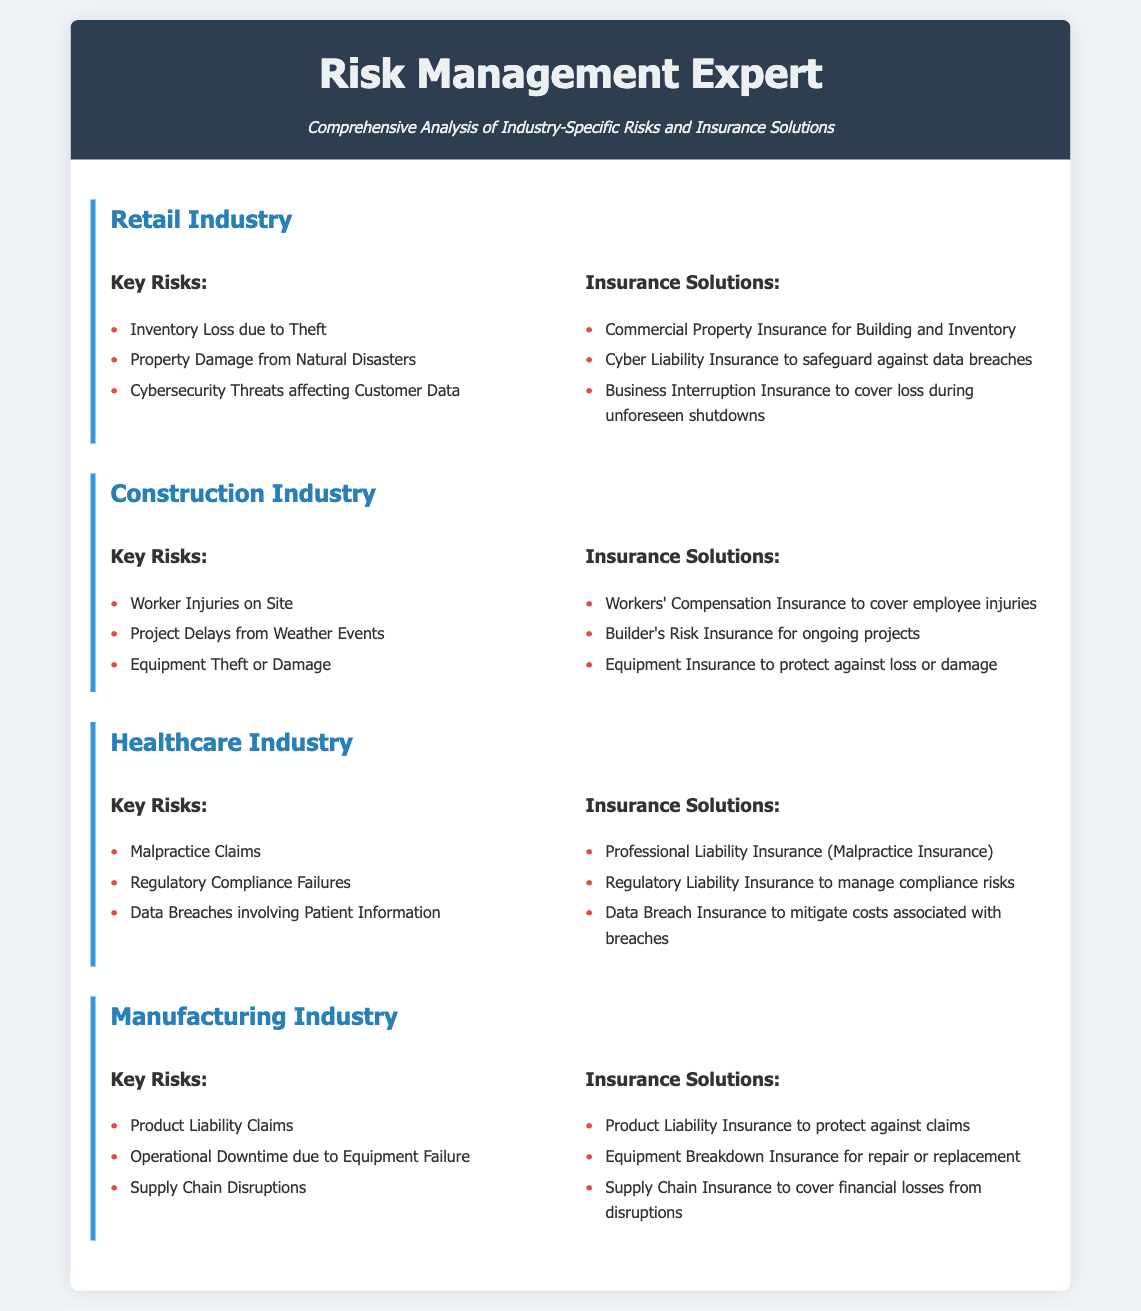What are the key risks in the Retail Industry? The key risks listed are Inventory Loss due to Theft, Property Damage from Natural Disasters, and Cybersecurity Threats affecting Customer Data.
Answer: Inventory Loss due to Theft, Property Damage from Natural Disasters, Cybersecurity Threats affecting Customer Data What type of insurance protects against worker injuries in the Construction Industry? The specific insurance mentioned for worker injuries is Workers' Compensation Insurance.
Answer: Workers' Compensation Insurance What is one solution for managing cybersecurity threats in the Retail Industry? The document specifies Cyber Liability Insurance as a solution for safeguarding against data breaches.
Answer: Cyber Liability Insurance How many key risks are mentioned in the Healthcare Industry? The document lists three key risks in the Healthcare Industry: Malpractice Claims, Regulatory Compliance Failures, and Data Breaches involving Patient Information.
Answer: Three What insurance is suggested for equipment theft in the Construction Industry? Equipment Insurance is recommended to protect against loss or damage of equipment in the Construction Industry.
Answer: Equipment Insurance What is the insurance solution for product liability in the Manufacturing Industry? Product Liability Insurance is identified as the insurance solution to protect against claims in the Manufacturing Industry.
Answer: Product Liability Insurance Which industry involves regulatory compliance failures as a key risk? The Healthcare Industry includes regulatory compliance failures among its key risks.
Answer: Healthcare Industry What are the two types of insurance solutions for the Manufacturing Industry? The document lists Product Liability Insurance and Equipment Breakdown Insurance as solutions for the Manufacturing Industry.
Answer: Product Liability Insurance, Equipment Breakdown Insurance 